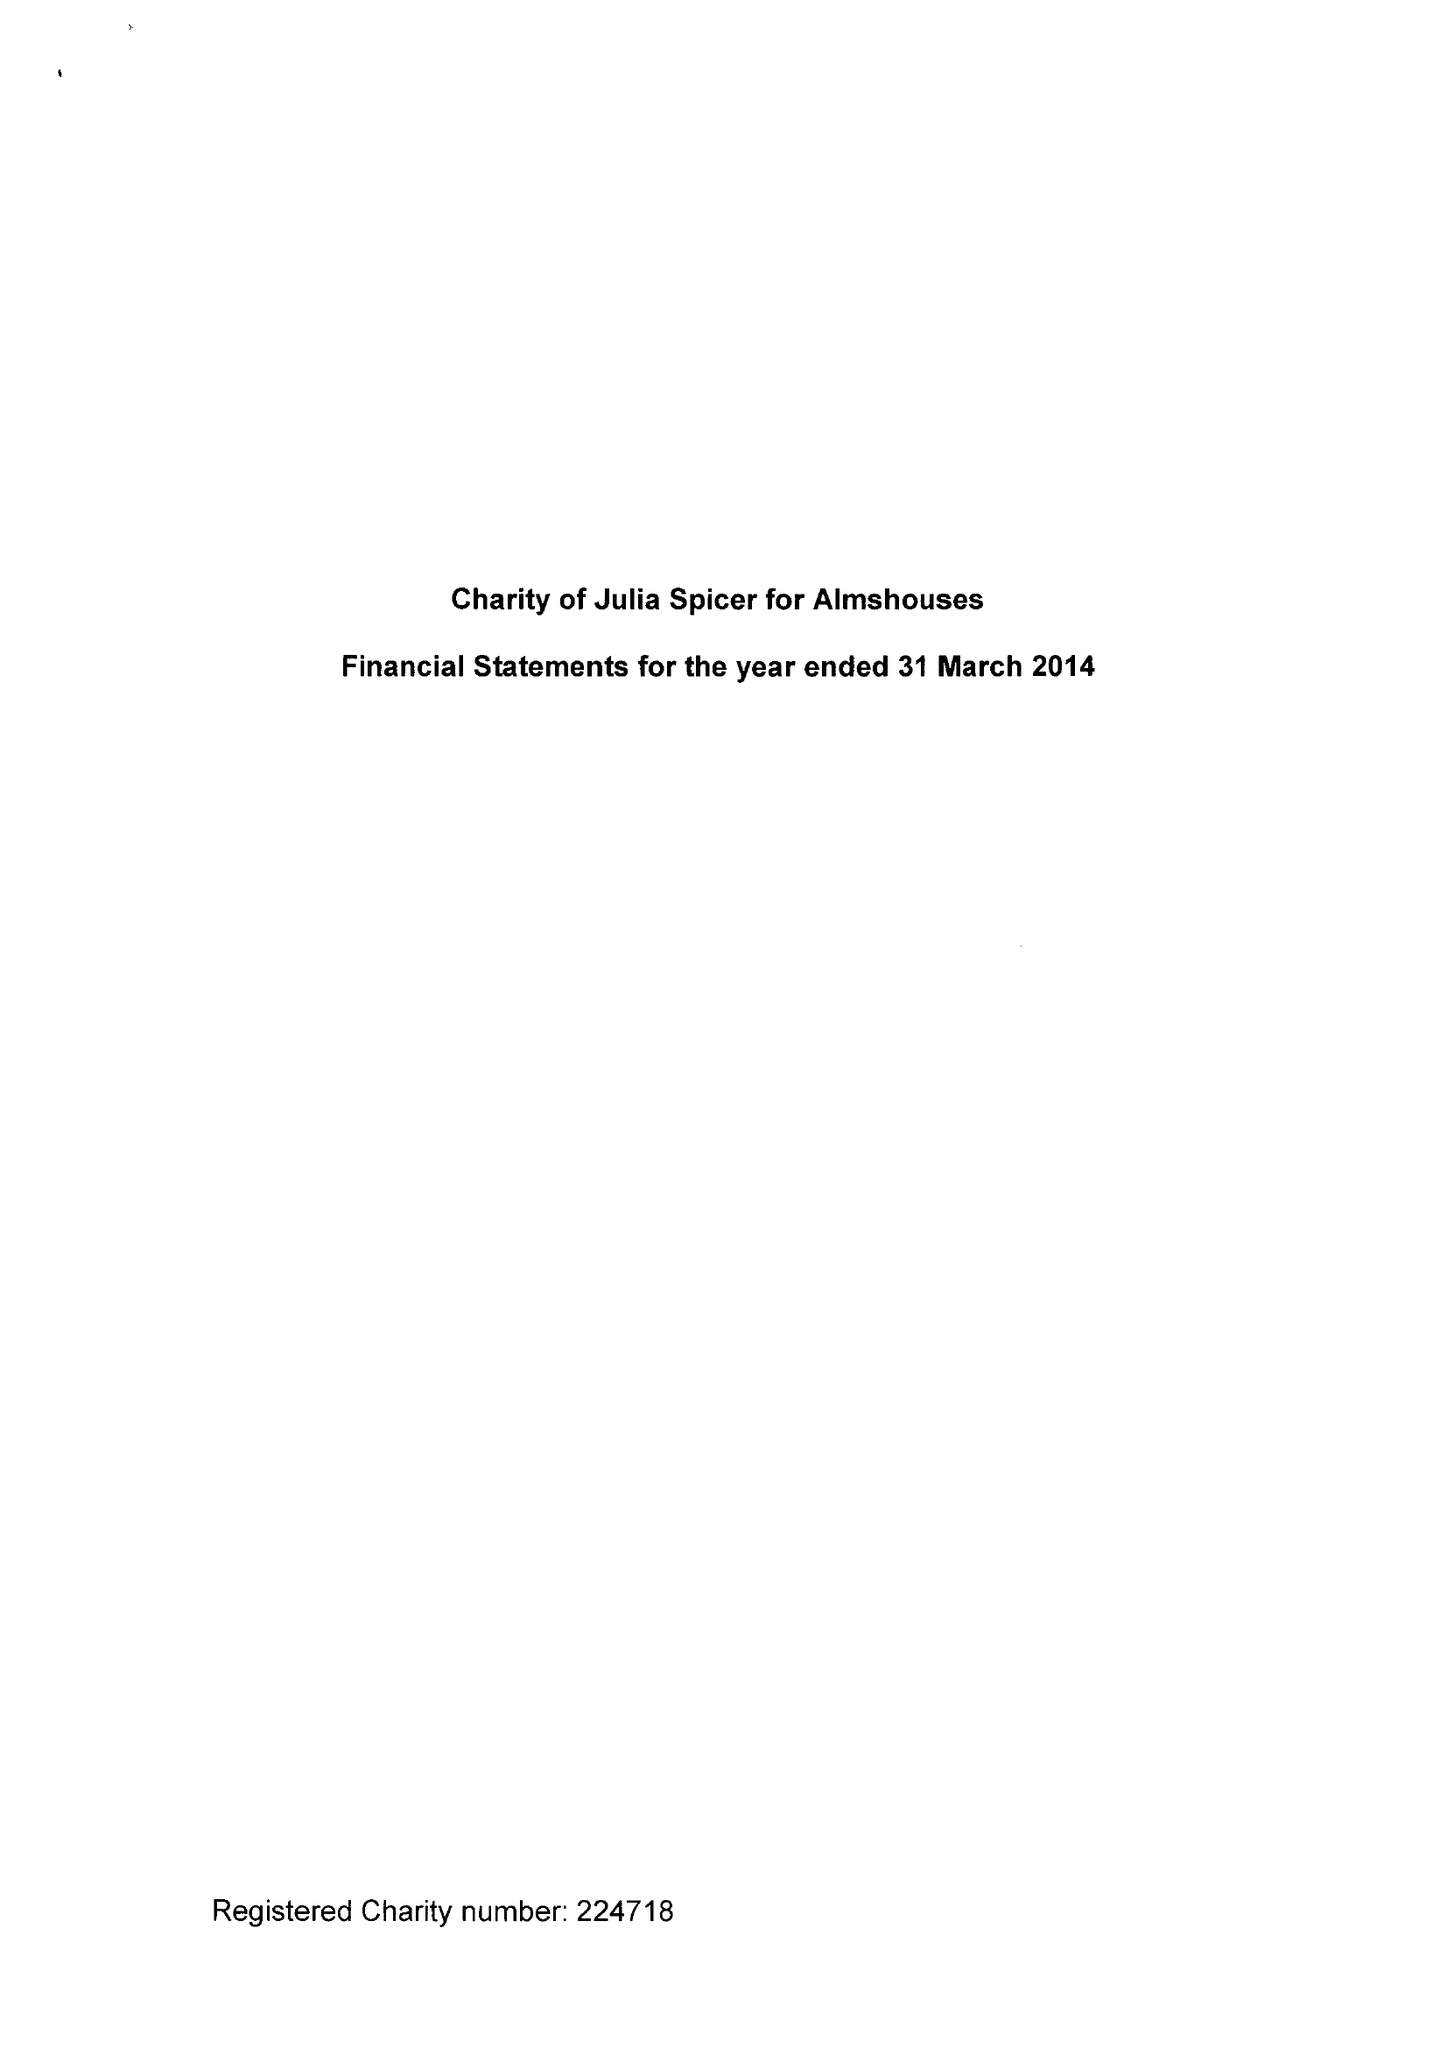What is the value for the address__post_town?
Answer the question using a single word or phrase. CROYDON 